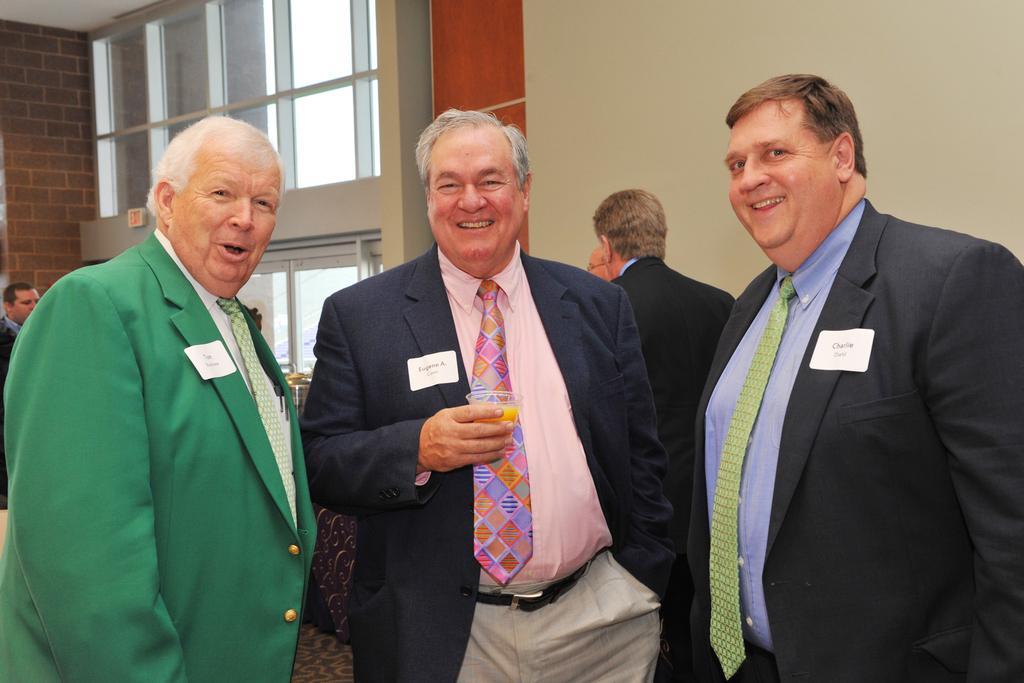Please provide a concise description of this image. In the foreground of this image, there are three men in suits and a man is holding a glass. Behind them, there are men, wall and the glass windows. 